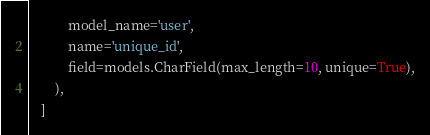Convert code to text. <code><loc_0><loc_0><loc_500><loc_500><_Python_>            model_name='user',
            name='unique_id',
            field=models.CharField(max_length=10, unique=True),
        ),
    ]
</code> 